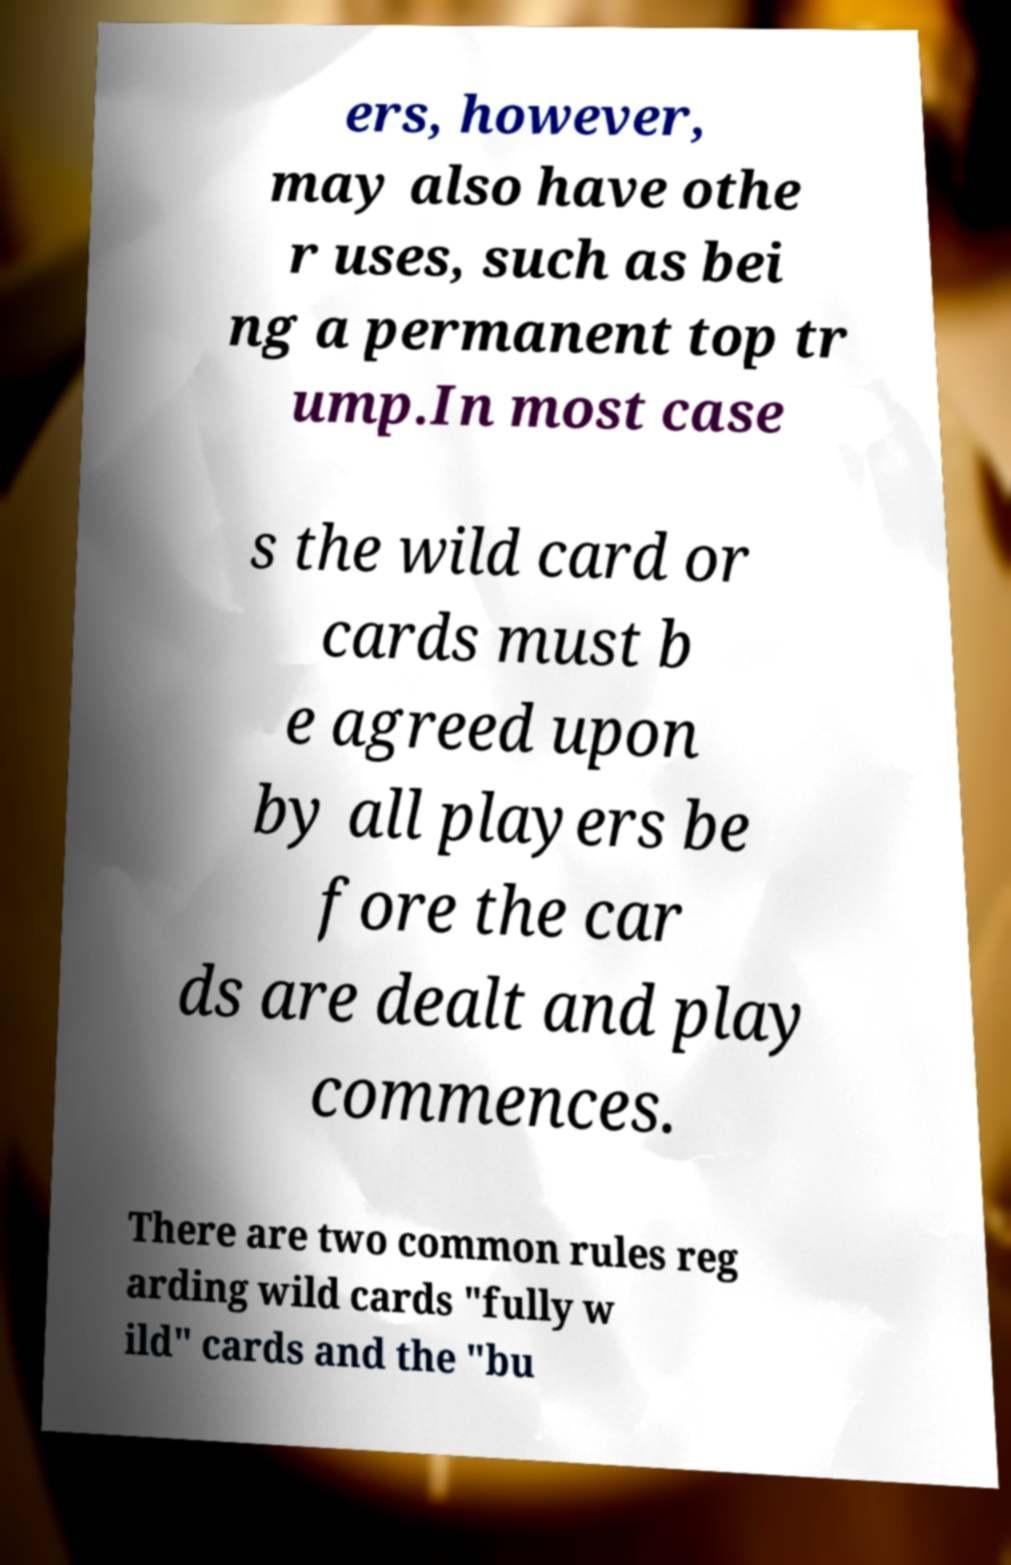There's text embedded in this image that I need extracted. Can you transcribe it verbatim? ers, however, may also have othe r uses, such as bei ng a permanent top tr ump.In most case s the wild card or cards must b e agreed upon by all players be fore the car ds are dealt and play commences. There are two common rules reg arding wild cards "fully w ild" cards and the "bu 